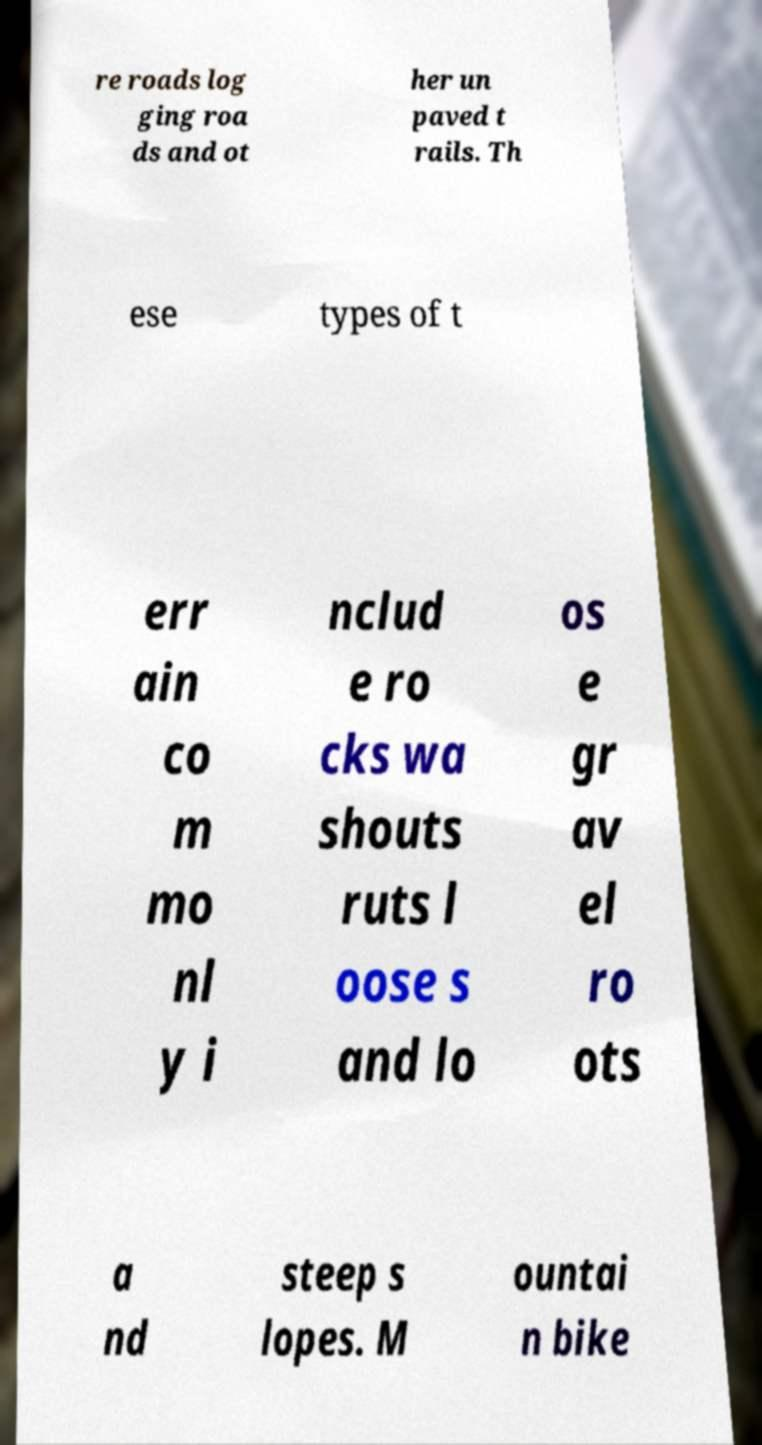Can you read and provide the text displayed in the image?This photo seems to have some interesting text. Can you extract and type it out for me? re roads log ging roa ds and ot her un paved t rails. Th ese types of t err ain co m mo nl y i nclud e ro cks wa shouts ruts l oose s and lo os e gr av el ro ots a nd steep s lopes. M ountai n bike 